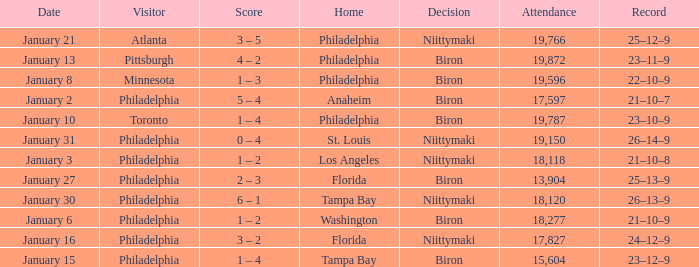What is the decision of the game on January 13? Biron. 